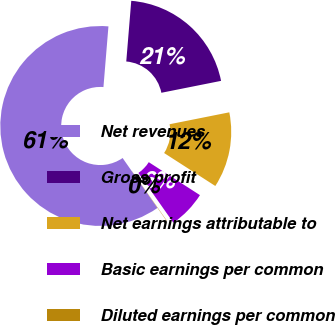Convert chart to OTSL. <chart><loc_0><loc_0><loc_500><loc_500><pie_chart><fcel>Net revenues<fcel>Gross profit<fcel>Net earnings attributable to<fcel>Basic earnings per common<fcel>Diluted earnings per common<nl><fcel>61.01%<fcel>20.56%<fcel>12.24%<fcel>6.14%<fcel>0.05%<nl></chart> 